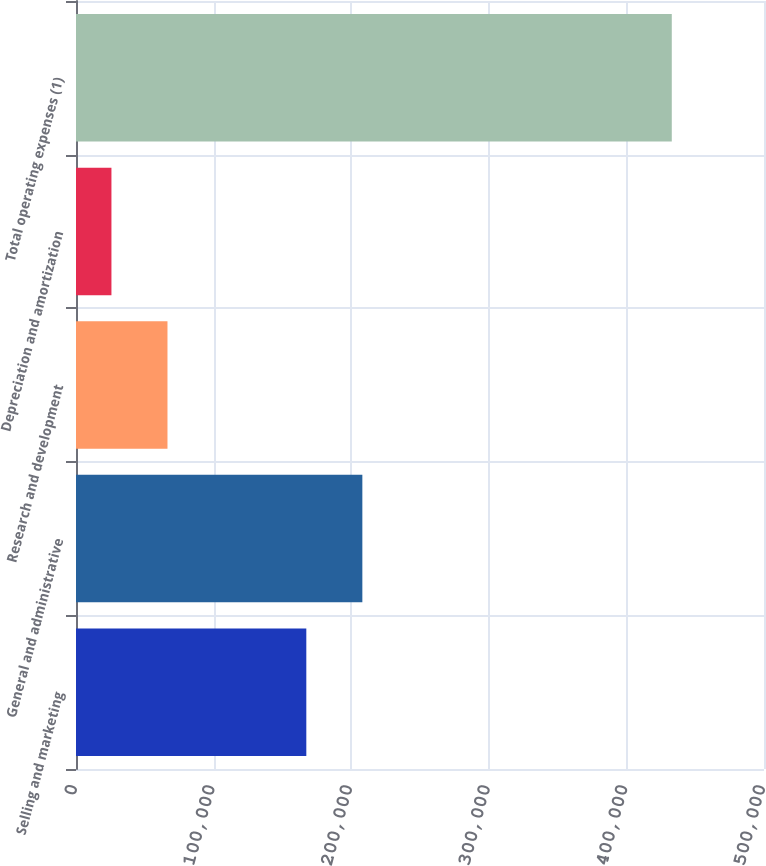Convert chart to OTSL. <chart><loc_0><loc_0><loc_500><loc_500><bar_chart><fcel>Selling and marketing<fcel>General and administrative<fcel>Research and development<fcel>Depreciation and amortization<fcel>Total operating expenses (1)<nl><fcel>167380<fcel>208103<fcel>66477.7<fcel>25755<fcel>432982<nl></chart> 